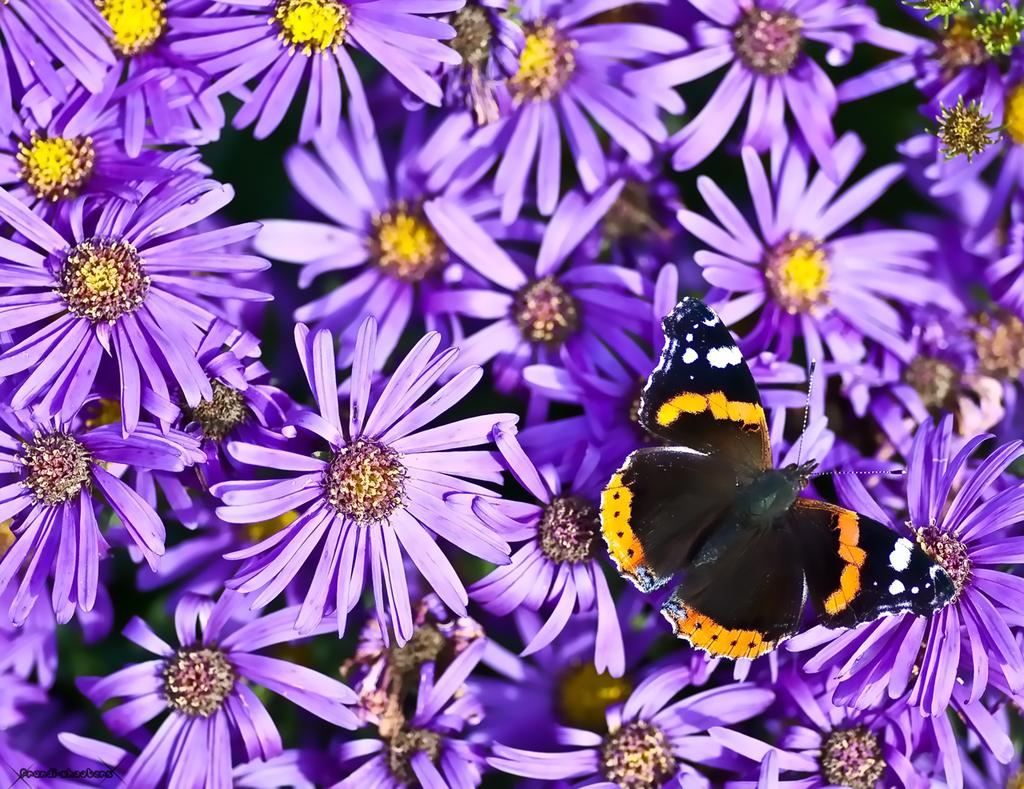What type of living organisms can be seen in the image? There are flowers and a butterfly in the image. Can you describe the butterfly in the image? The butterfly is a colorful insect with wings. What might the butterfly be doing in the image? The butterfly might be flying or resting on the flowers. What type of dish is the cook preparing for dad in the image? There is no cook, dad, or dish being prepared in the image; it only features flowers and a butterfly. 